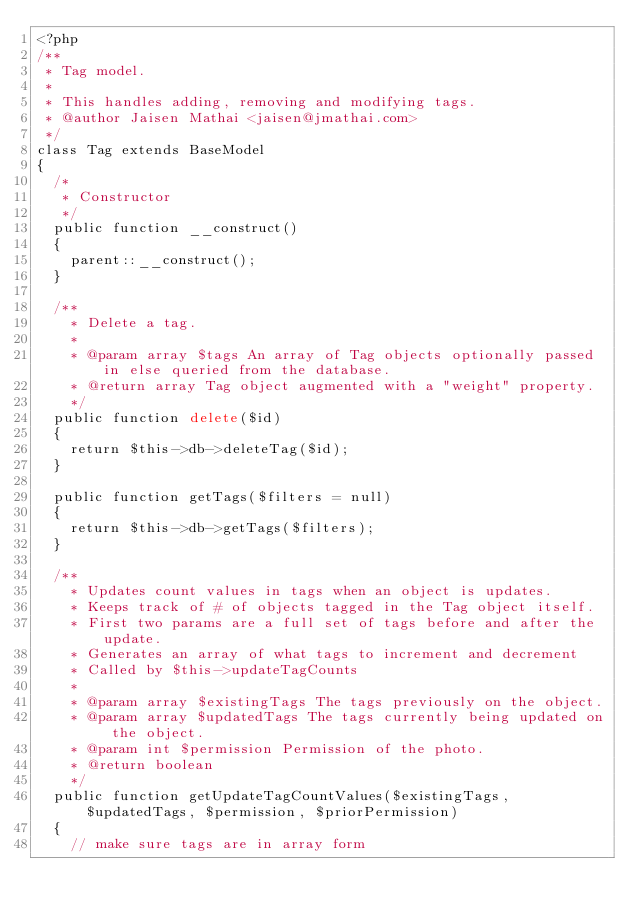Convert code to text. <code><loc_0><loc_0><loc_500><loc_500><_PHP_><?php
/**
 * Tag model.
 *
 * This handles adding, removing and modifying tags.
 * @author Jaisen Mathai <jaisen@jmathai.com>
 */
class Tag extends BaseModel
{
  /*
   * Constructor
   */
  public function __construct()
  {
    parent::__construct();
  }

  /**
    * Delete a tag.
    *
    * @param array $tags An array of Tag objects optionally passed in else queried from the database.
    * @return array Tag object augmented with a "weight" property.
    */
  public function delete($id)
  {
    return $this->db->deleteTag($id);
  }

  public function getTags($filters = null)
  {
    return $this->db->getTags($filters);
  }

  /**
    * Updates count values in tags when an object is updates.
    * Keeps track of # of objects tagged in the Tag object itself.
    * First two params are a full set of tags before and after the update.
    * Generates an array of what tags to increment and decrement
    * Called by $this->updateTagCounts
    *
    * @param array $existingTags The tags previously on the object.
    * @param array $updatedTags The tags currently being updated on the object.
    * @param int $permission Permission of the photo.
    * @return boolean
    */
  public function getUpdateTagCountValues($existingTags, $updatedTags, $permission, $priorPermission)
  {
    // make sure tags are in array form</code> 